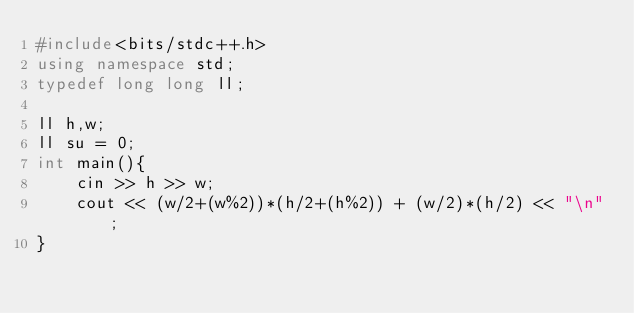Convert code to text. <code><loc_0><loc_0><loc_500><loc_500><_C++_>#include<bits/stdc++.h>
using namespace std;
typedef long long ll;

ll h,w;
ll su = 0;
int main(){
	cin >> h >> w;
	cout << (w/2+(w%2))*(h/2+(h%2)) + (w/2)*(h/2) << "\n";
}
</code> 